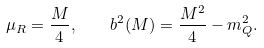Convert formula to latex. <formula><loc_0><loc_0><loc_500><loc_500>\mu _ { R } = \frac { M } { 4 } , \quad b ^ { 2 } ( M ) = \frac { M ^ { 2 } } { 4 } - m _ { Q } ^ { 2 } .</formula> 